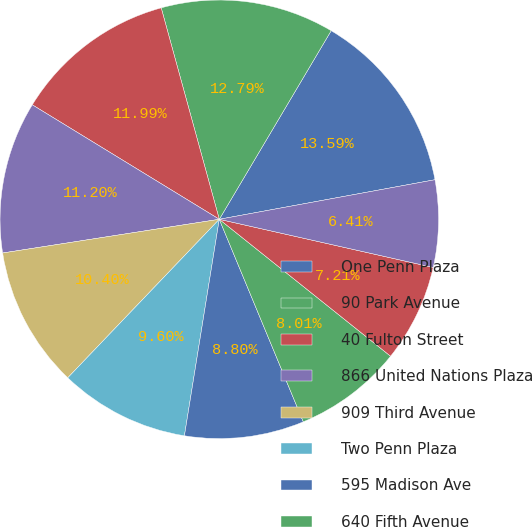<chart> <loc_0><loc_0><loc_500><loc_500><pie_chart><fcel>One Penn Plaza<fcel>90 Park Avenue<fcel>40 Fulton Street<fcel>866 United Nations Plaza<fcel>909 Third Avenue<fcel>Two Penn Plaza<fcel>595 Madison Ave<fcel>640 Fifth Avenue<fcel>Manhattan Mall<fcel>Eleven Penn Plaza<nl><fcel>13.59%<fcel>12.79%<fcel>11.99%<fcel>11.2%<fcel>10.4%<fcel>9.6%<fcel>8.8%<fcel>8.01%<fcel>7.21%<fcel>6.41%<nl></chart> 